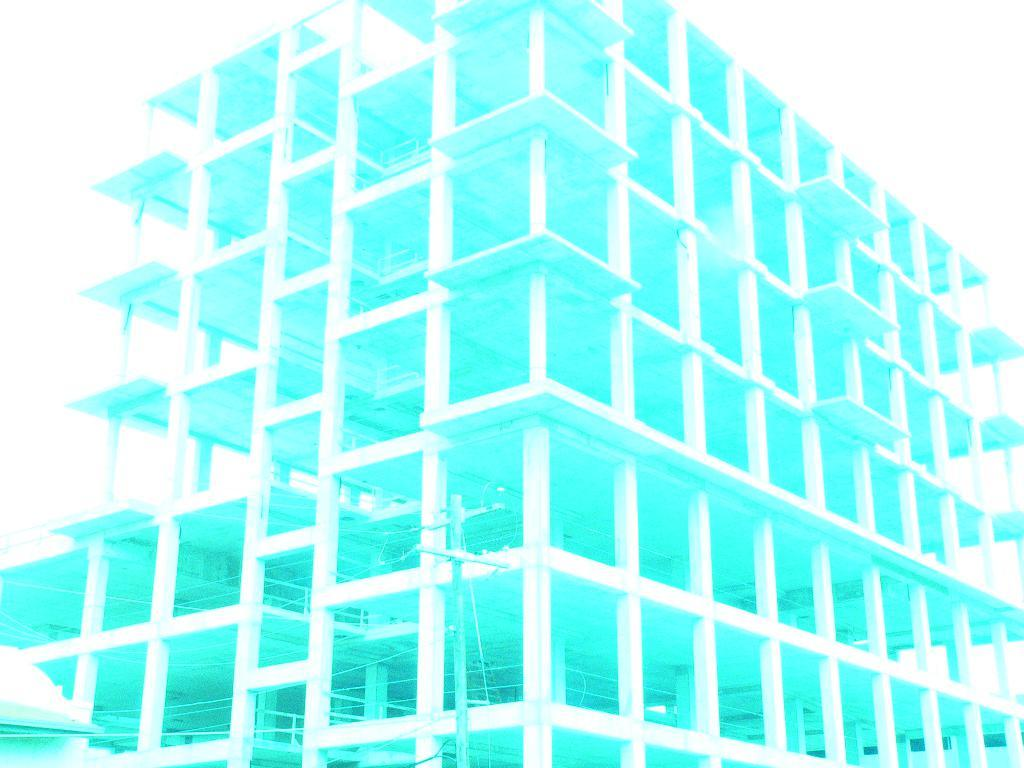What type of structure is present in the image? There is a building in the image. What other objects can be seen related to electricity? There are current poles and wires in the image. What color can be observed in the image? There is a blue shade visible in the image. What type of lipstick is the person wearing in the image? There is no person or lipstick present in the image; it features a building, current poles, wires, and a blue shade. 